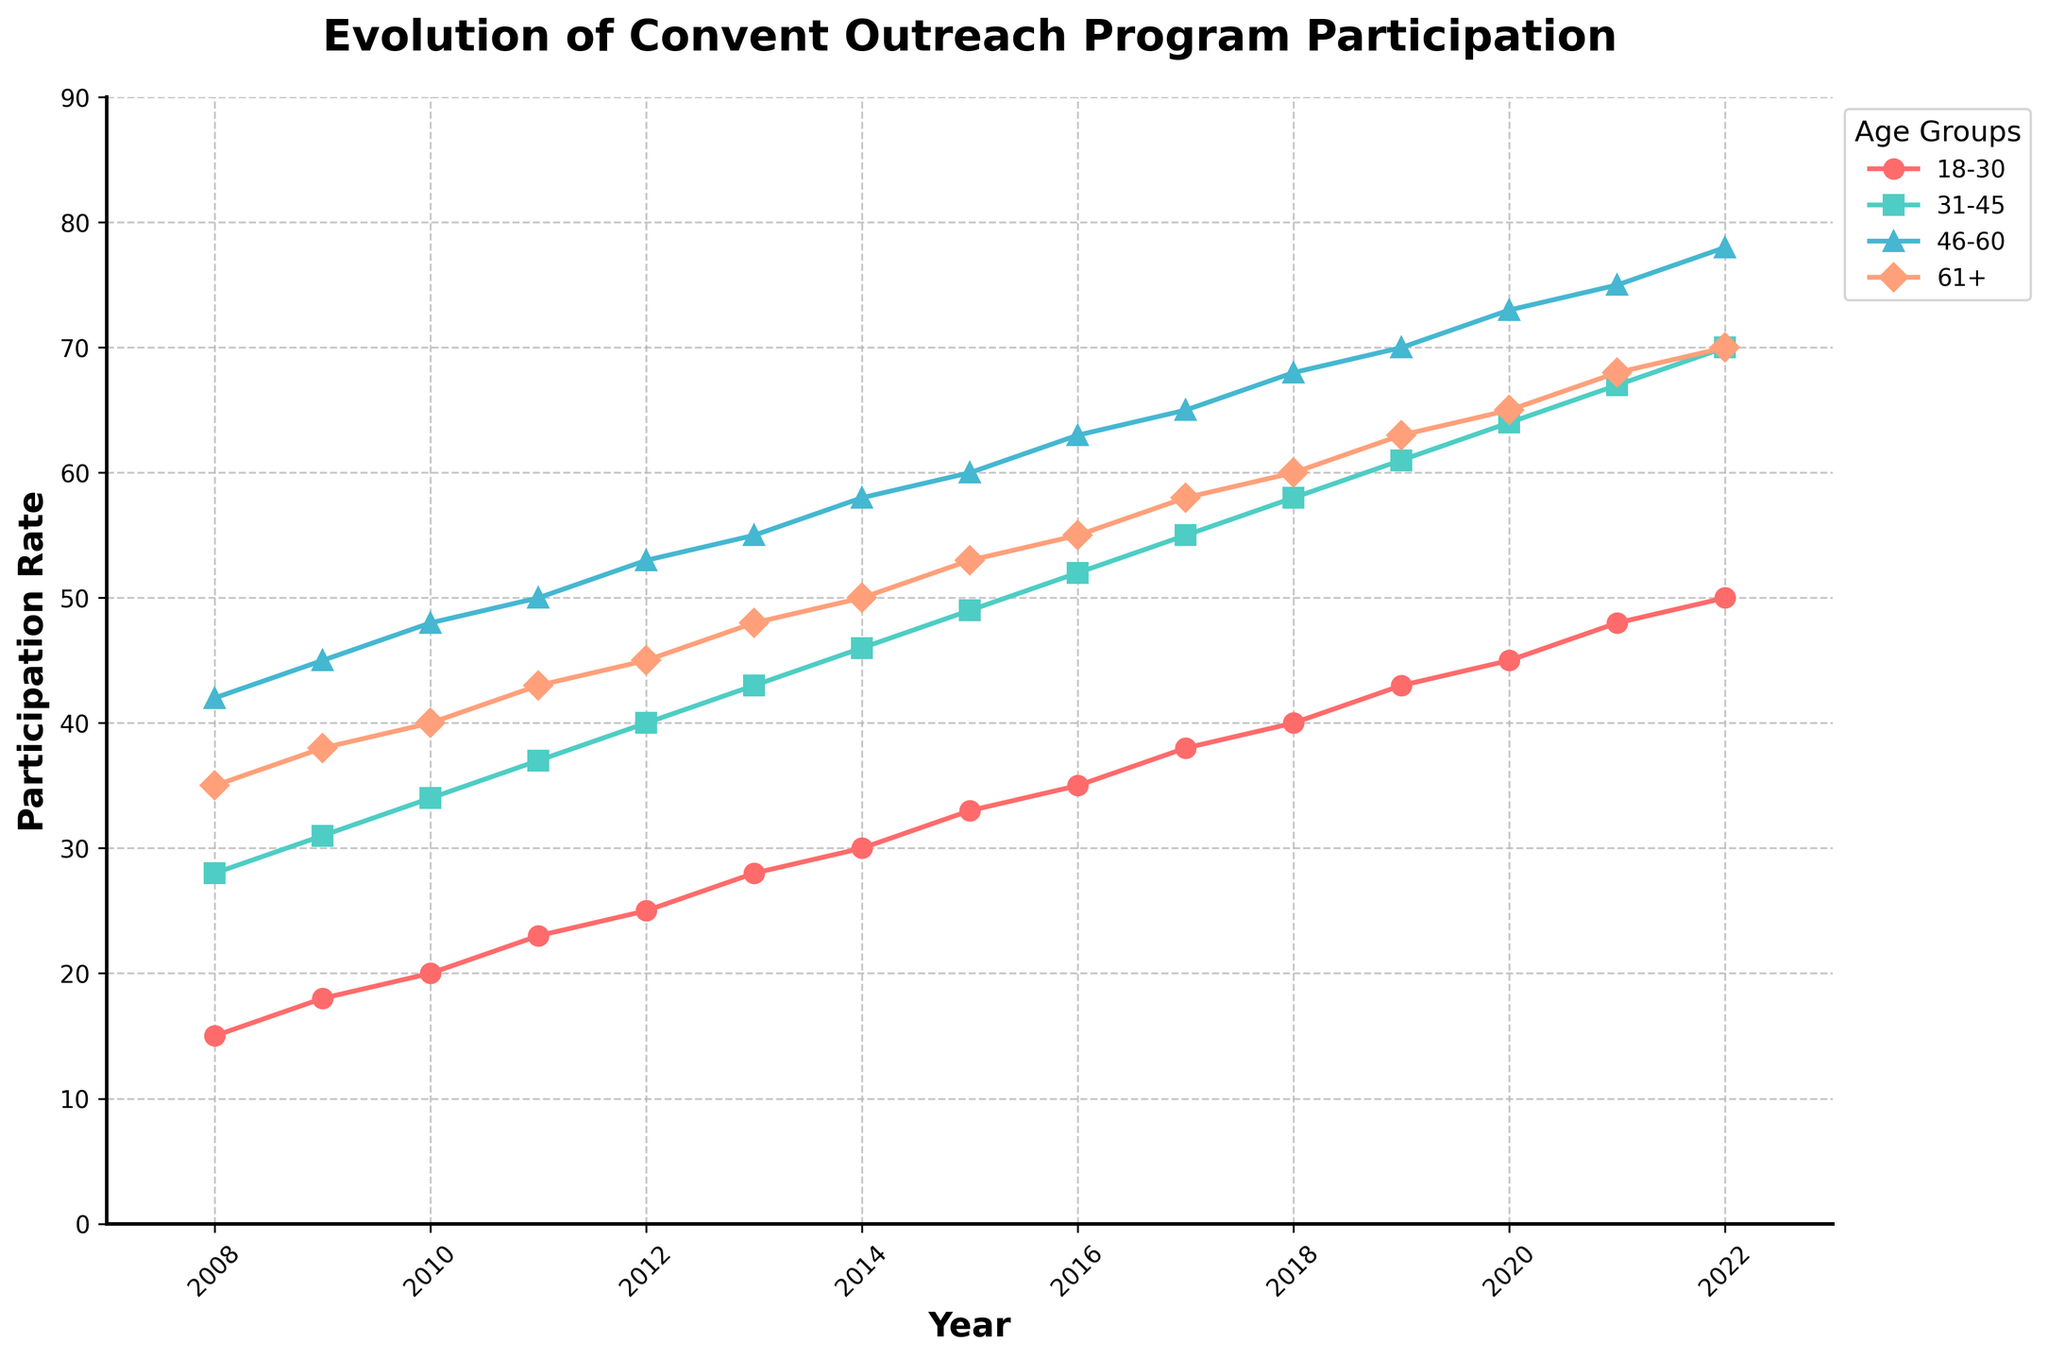What is the overall trend in the participation rates for the 18-30 age group from 2008 to 2022? The participation rate for the 18-30 age group shows a consistent increase from 2008 to 2022. It starts at 15 in 2008 and increases to 50 in 2022. This indicates a steady rise over the years.
Answer: Steady increase Which age group had the highest participation rate in 2022? To determine this, compare the participation rates for all age groups in 2022. The rates are: 18-30: 50, 31-45: 70, 46-60: 78, 61+: 70. The 46-60 age group has the highest rate with 78.
Answer: 46-60 What is the difference in participation rates between the 31-45 age group and the 61+ age group in 2020? The participation rates in 2020 for the 31-45 and 61+ age groups are 64 and 65, respectively. The difference is 65 - 64 = 1.
Answer: 1 Between which two consecutive years did the 46-60 age group see the largest increase in participation rate? Look at the differences in participation rates between consecutive years for 46-60. The largest difference occurs from 2009 (45) to 2010 (48), an increase of 3. However, a larger increment happens from 2019 (70) to 2020 (73), an increase of 3. Therefore, the biggest increase of 3 happens from 2019 to 2020.
Answer: 2019 to 2020 Which age group had the most consistent increase in participation rate? By visually inspecting the plot, the 18-30 age group has the most consistent and uniform increase in participation rate from year to year.
Answer: 18-30 By how much did the participation rate for the 61+ age group increase from 2008 to 2022? The participation rate for the 61+ age group increased from 35 in 2008 to 70 in 2022. The increase is calculated as 70 - 35 = 35.
Answer: 35 What was the average participation rate of the 31-45 age group from 2008 to 2022? Sum the participation rates of the 31-45 age group from 2008 to 2022, then divide by the number of years. The sum is 775 and the number of years is 15. The average is 775 / 15 = ~51.67.
Answer: ~51.67 How does the participation rate of the 18-30 age group in 2015 compare to that of the 31-45 age group in the same year? In 2015, the participation rate for the 18-30 age group is 33, and for the 31-45 age group, it is 49. Thus, the 18-30 age group has a lower rate compared to the 31-45 age group.
Answer: Lower Which age group saw a higher percentage increase in participation rate from 2008 to 2022: 18-30 or 61+? Calculate the percentage increase for both groups. For 18-30, (50 - 15) / 15 * 100 = 233.33%. For 61+, (70 - 35) / 35 * 100 = 100%. The 18-30 age group saw a higher percentage increase.
Answer: 18-30 